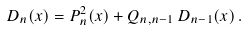<formula> <loc_0><loc_0><loc_500><loc_500>D _ { n } ( x ) = P _ { n } ^ { 2 } ( x ) + Q _ { n , n - 1 } \, D _ { n - 1 } ( x ) \, .</formula> 